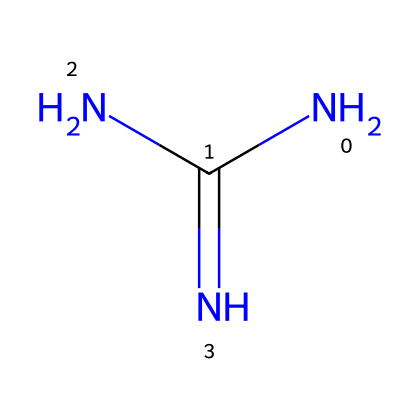What is the molecular formula of this compound? By analyzing the SMILES representation NC(N)=N, we can count the number of Nitrogen (N) and Carbon (C) atoms. There are 3 Nitrogen atoms and 1 Carbon atom, leading to the molecular formula C1N3.
Answer: C1N3 How many nitrogen atoms are present in this molecule? In the SMILES representation, NC(N)=N shows that there are three Nitrogen (N) symbols present; thus, the count of nitrogen atoms is three.
Answer: 3 What type of chemical bond is present between the nitrogen atoms? The presence of the "=" sign between the nitrogen atoms in the representation indicates that there is a double bond between them.
Answer: double bond Is guanidine a strong or weak base? Guanidine is known to be a strong organic base, which is evident from its structure possessing a highly basic nitrogen arrangement.
Answer: strong What type of reactions can this chemical undergo? Guanidine can undergo protonation reactions due to its basic nature, where it can accept protons (H+), highlighting its ability to participate in acid-base reactions.
Answer: protonation reactions Does this chemical contain any functional groups? The structure of guanidine, represented in the SMILES as NC(N)=N, displays an amino group (-NH2) and indicates that it is indeed an organic base with functional characteristics.
Answer: amino group 